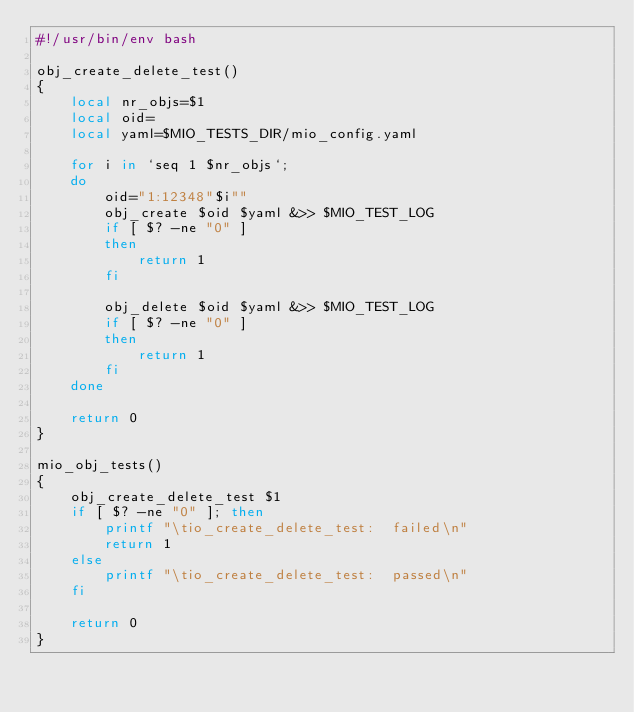<code> <loc_0><loc_0><loc_500><loc_500><_Bash_>#!/usr/bin/env bash

obj_create_delete_test()
{
	local nr_objs=$1
	local oid=
	local yaml=$MIO_TESTS_DIR/mio_config.yaml

	for i in `seq 1 $nr_objs`;
	do
		oid="1:12348"$i""
		obj_create $oid $yaml &>> $MIO_TEST_LOG
		if [ $? -ne "0" ]
		then
			return 1
		fi

		obj_delete $oid $yaml &>> $MIO_TEST_LOG
		if [ $? -ne "0" ]
		then
			return 1
		fi
	done

	return 0
}

mio_obj_tests()
{
	obj_create_delete_test $1
	if [ $? -ne "0" ]; then
		printf "\tio_create_delete_test:  failed\n"
		return 1
	else
		printf "\tio_create_delete_test:  passed\n"
	fi

	return 0
}
</code> 